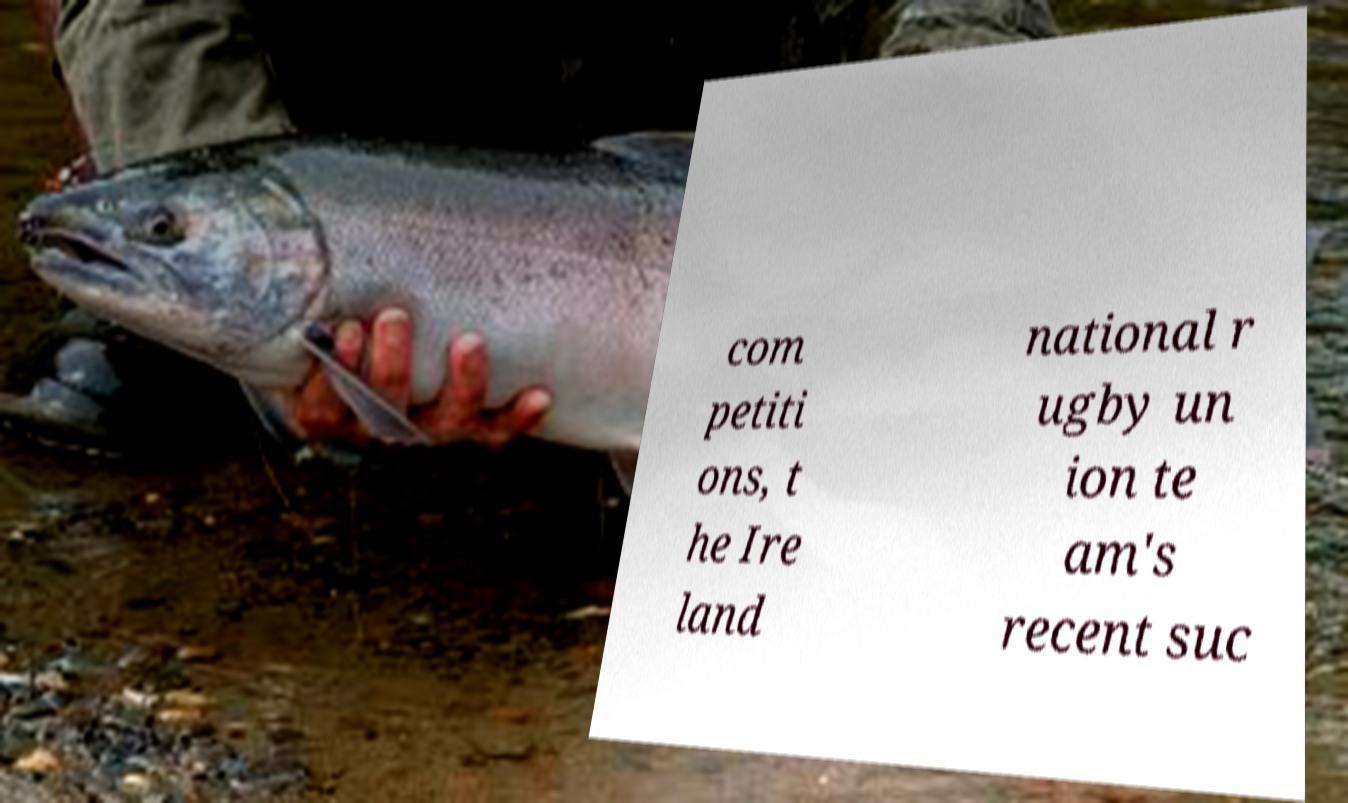Please read and relay the text visible in this image. What does it say? com petiti ons, t he Ire land national r ugby un ion te am's recent suc 